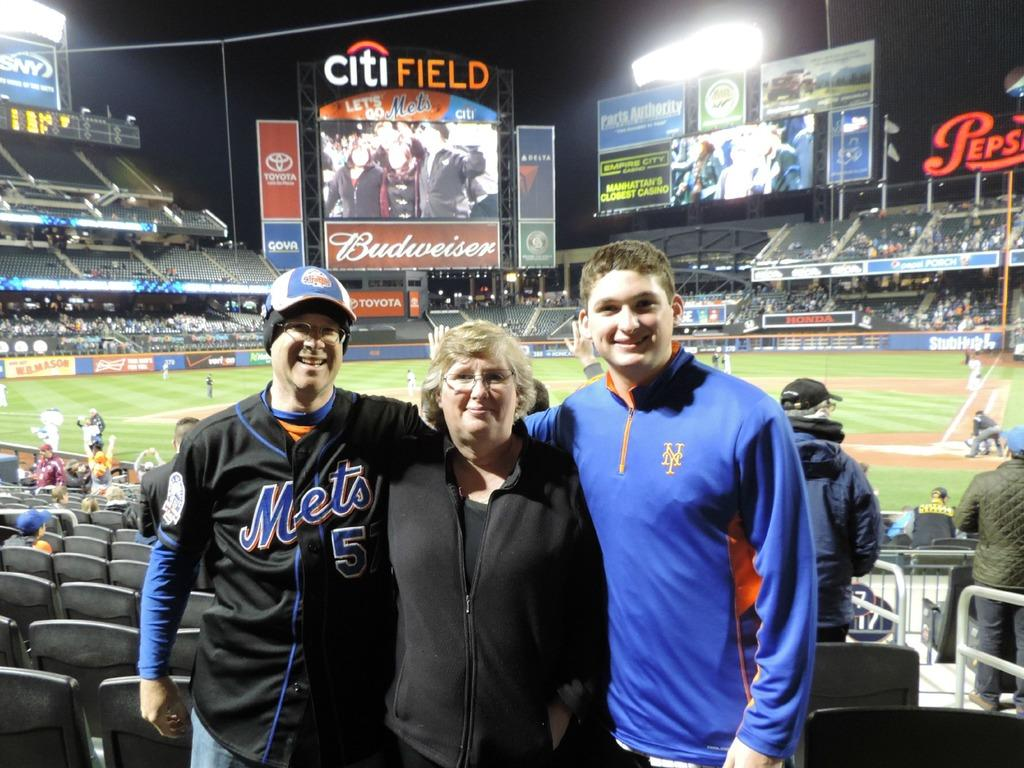<image>
Share a concise interpretation of the image provided. People posing for a photo while wearing a Mets jersey. 